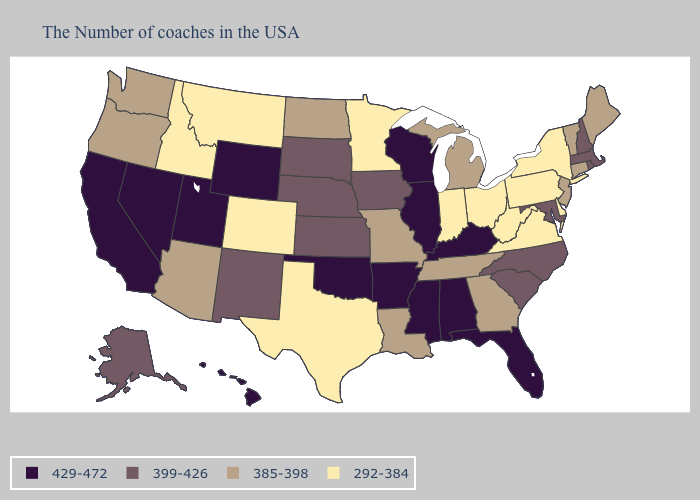What is the lowest value in states that border Kansas?
Answer briefly. 292-384. What is the value of Indiana?
Short answer required. 292-384. Among the states that border Pennsylvania , does Maryland have the highest value?
Be succinct. Yes. Among the states that border Arizona , does New Mexico have the lowest value?
Keep it brief. No. Which states have the lowest value in the West?
Concise answer only. Colorado, Montana, Idaho. Name the states that have a value in the range 385-398?
Answer briefly. Maine, Vermont, Connecticut, New Jersey, Georgia, Michigan, Tennessee, Louisiana, Missouri, North Dakota, Arizona, Washington, Oregon. What is the lowest value in states that border Oklahoma?
Write a very short answer. 292-384. Name the states that have a value in the range 292-384?
Write a very short answer. New York, Delaware, Pennsylvania, Virginia, West Virginia, Ohio, Indiana, Minnesota, Texas, Colorado, Montana, Idaho. Does Idaho have the lowest value in the USA?
Short answer required. Yes. What is the value of Colorado?
Short answer required. 292-384. Does the map have missing data?
Keep it brief. No. What is the value of Pennsylvania?
Concise answer only. 292-384. Is the legend a continuous bar?
Answer briefly. No. Among the states that border Wyoming , which have the highest value?
Be succinct. Utah. 